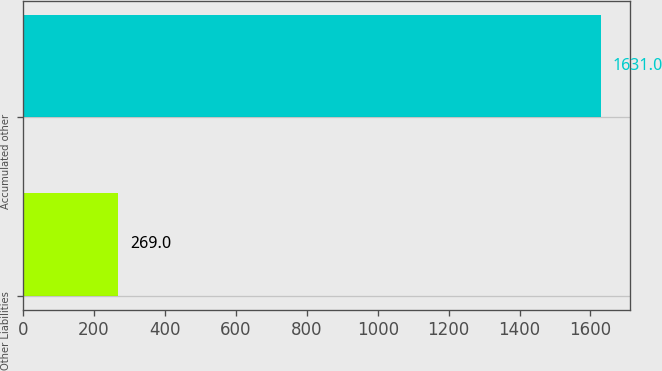Convert chart to OTSL. <chart><loc_0><loc_0><loc_500><loc_500><bar_chart><fcel>Other Liabilities<fcel>Accumulated other<nl><fcel>269<fcel>1631<nl></chart> 